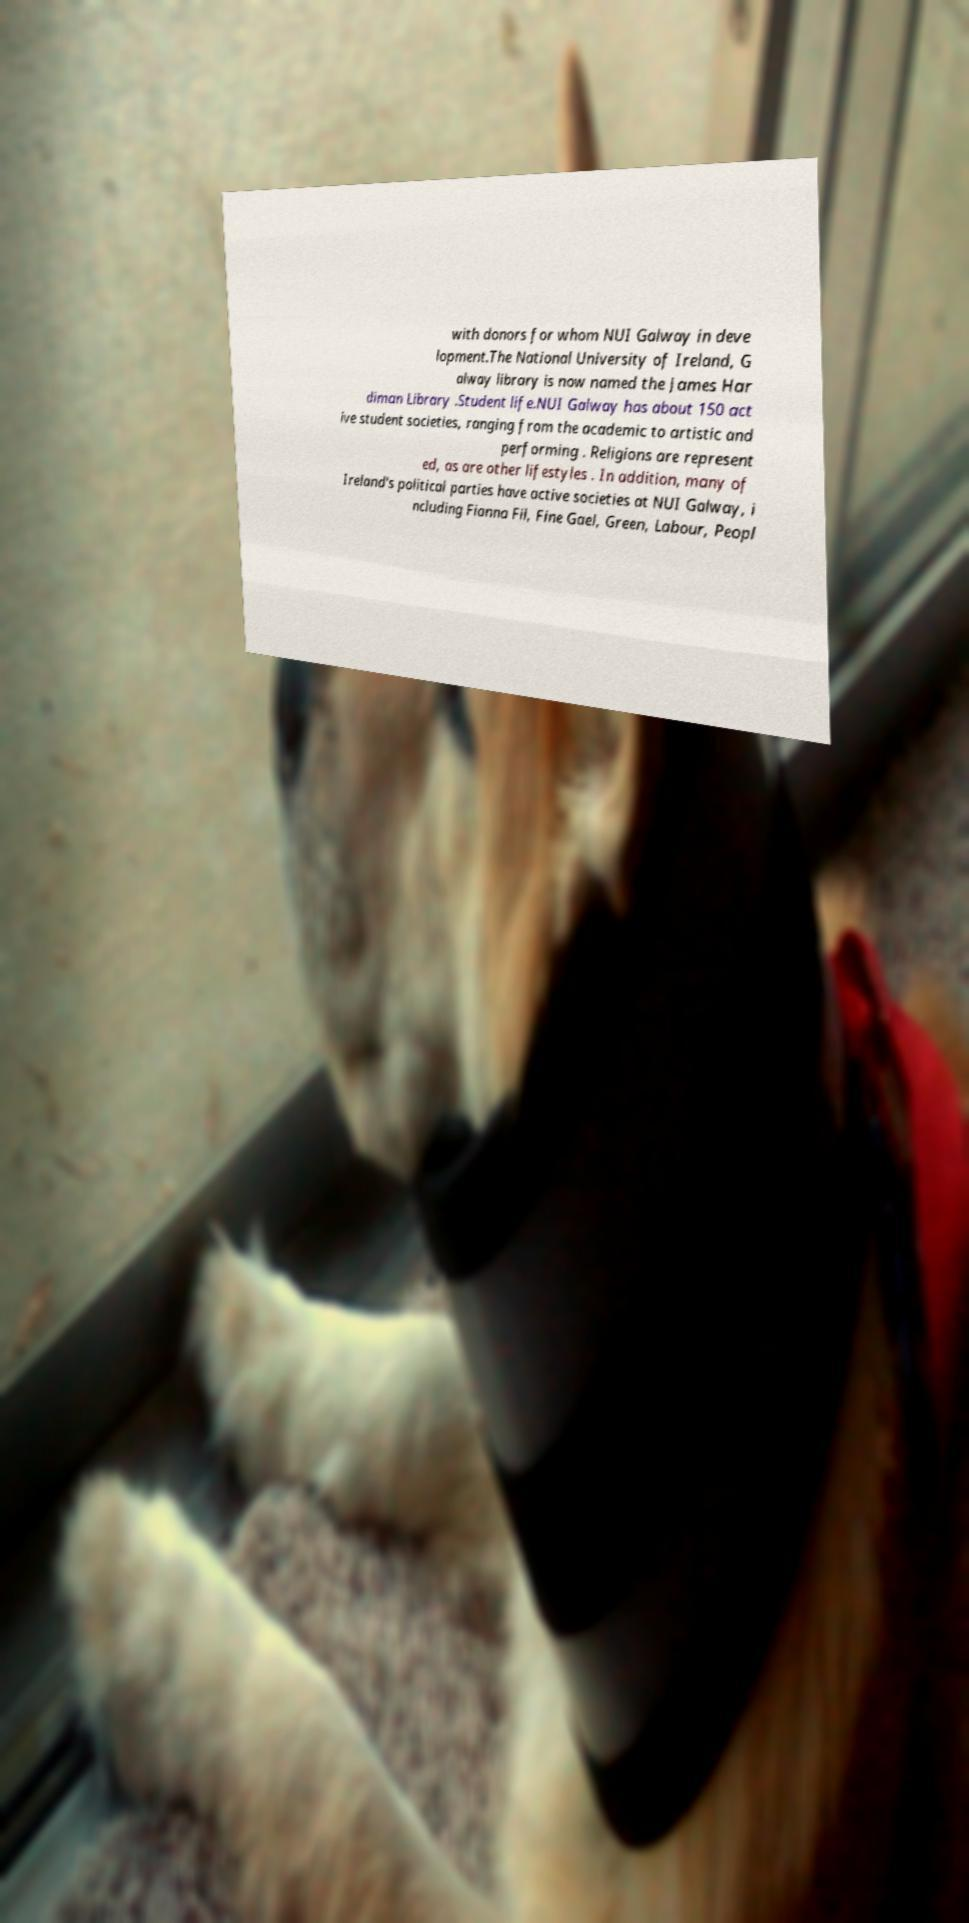There's text embedded in this image that I need extracted. Can you transcribe it verbatim? with donors for whom NUI Galway in deve lopment.The National University of Ireland, G alway library is now named the James Har diman Library .Student life.NUI Galway has about 150 act ive student societies, ranging from the academic to artistic and performing . Religions are represent ed, as are other lifestyles . In addition, many of Ireland's political parties have active societies at NUI Galway, i ncluding Fianna Fil, Fine Gael, Green, Labour, Peopl 